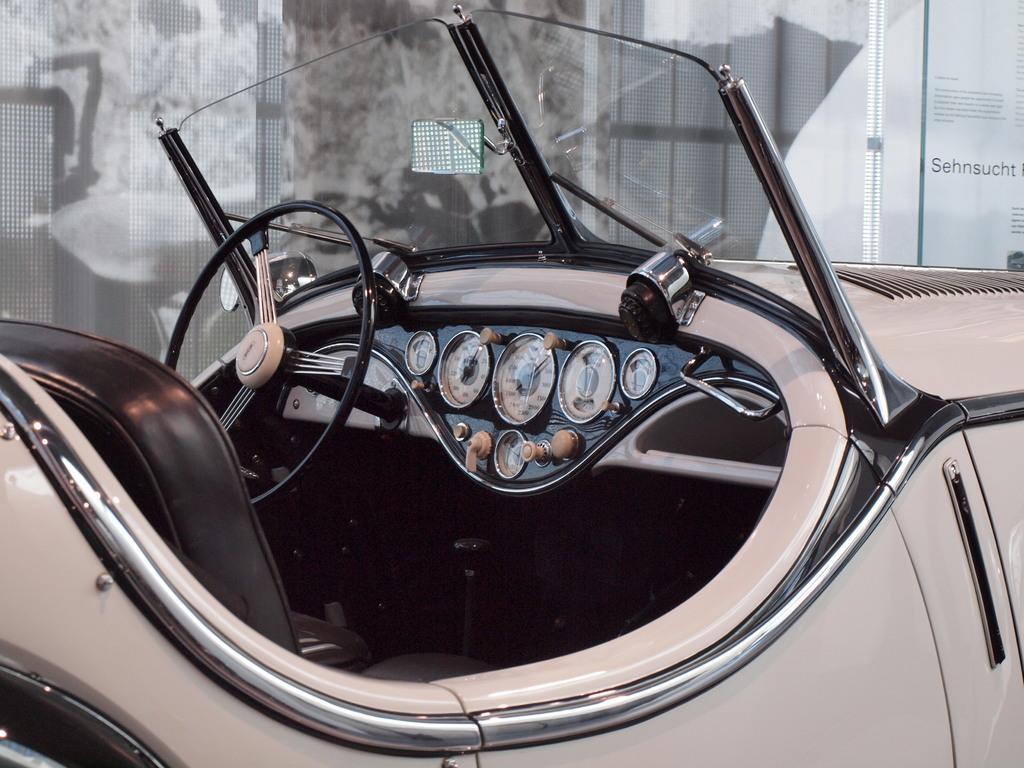Describe this image in one or two sentences. In this image we can see the side view of a vehicle and we can see the steering wheel, speed meters and some other things and on the right side of the image we can see some text. 